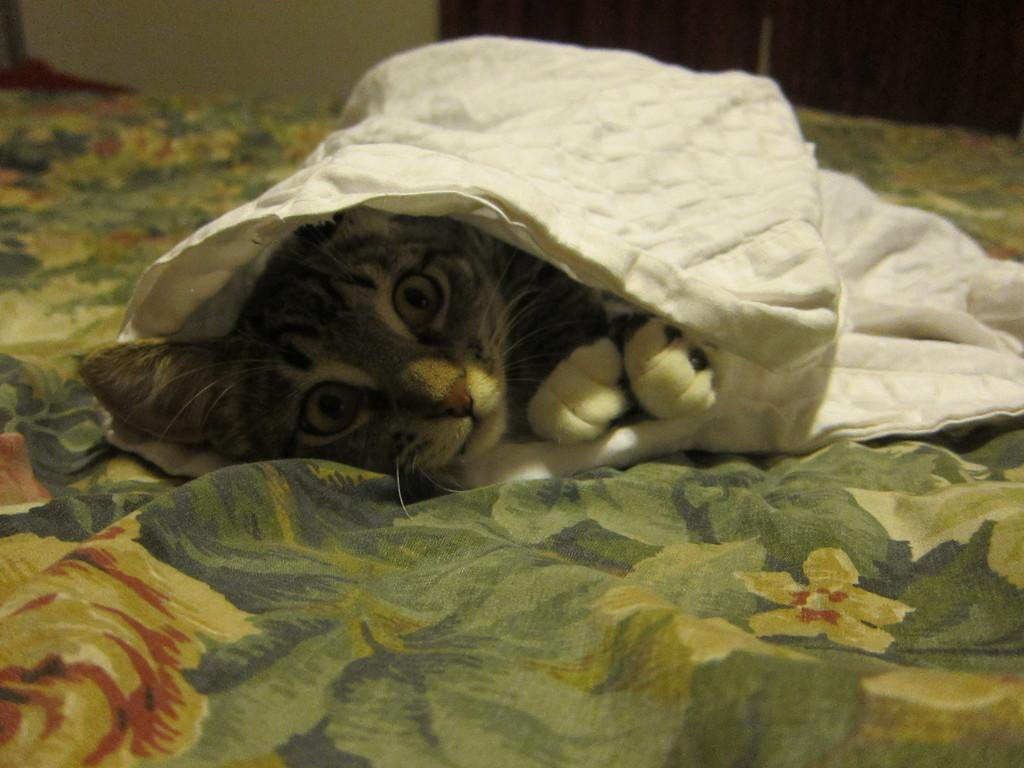What type of animal is in the image? There is a cat in the image. Where is the cat positioned in relation to the viewer? The cat is in front of the viewer. What is covering the cat? There is a white cloth on the cat. What is the cat lying on? The cat is lying on a couch. What type of knowledge can be gained from the cat's journey during the rainstorm in the image? There is no rainstorm or journey present in the image, and the cat is not depicted as having any knowledge. 